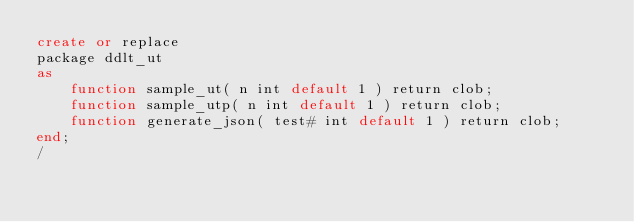<code> <loc_0><loc_0><loc_500><loc_500><_SQL_>create or replace
package ddlt_ut
as
    function sample_ut( n int default 1 ) return clob;
    function sample_utp( n int default 1 ) return clob;
    function generate_json( test# int default 1 ) return clob;
end;
/
</code> 